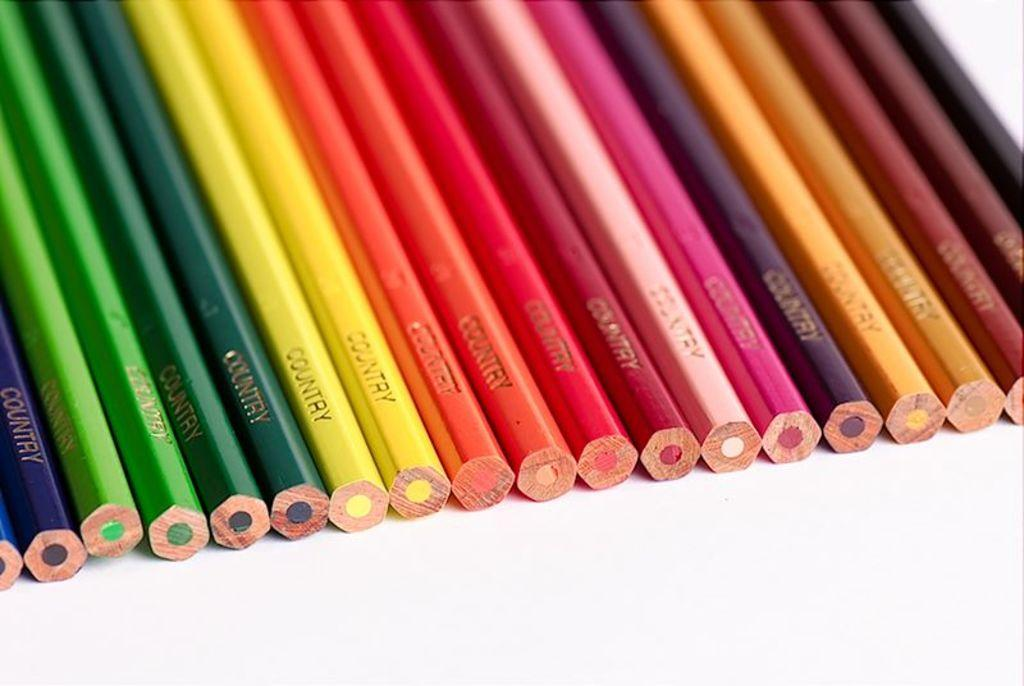<image>
Present a compact description of the photo's key features. All different colors of the brand country colored pencils. 